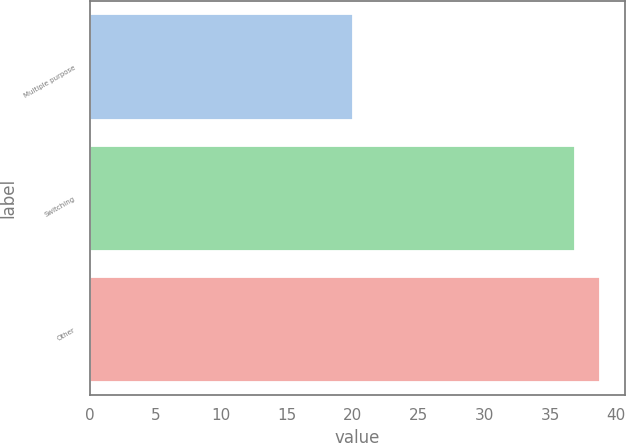Convert chart to OTSL. <chart><loc_0><loc_0><loc_500><loc_500><bar_chart><fcel>Multiple purpose<fcel>Switching<fcel>Other<nl><fcel>20<fcel>36.9<fcel>38.75<nl></chart> 